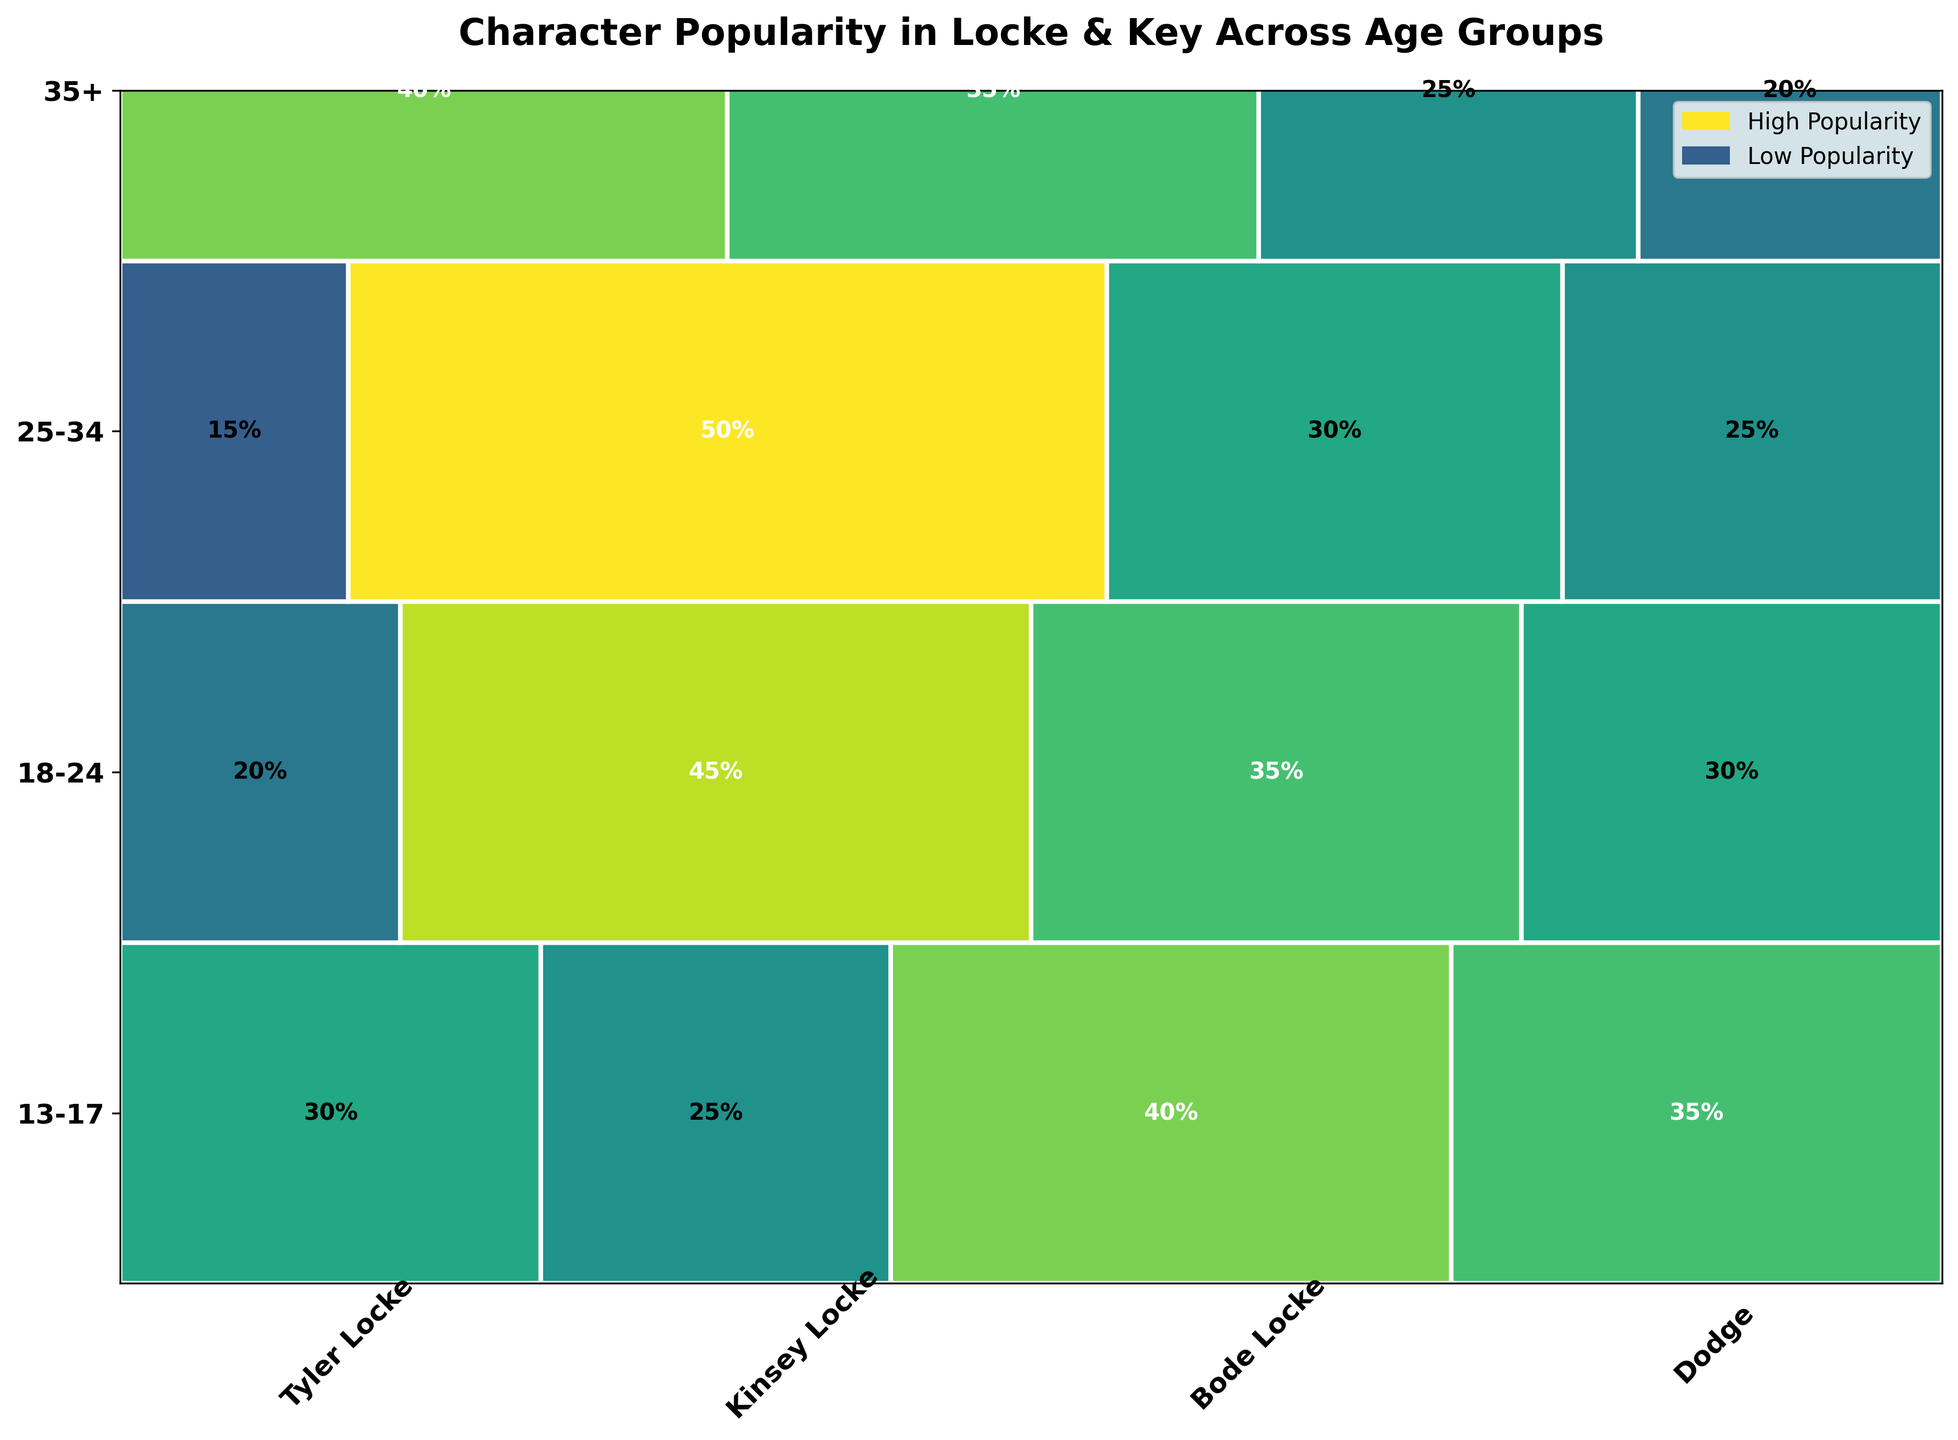Which age group has the highest preference for Dodge? To find the age group with the highest preference for Dodge, look at the section labeled Dodge and visually inspect the height across age groups. The bar for 25-34 is the tallest in the Dodge section.
Answer: 25-34 Who is the least popular character among fans aged 18-24? To identify the least popular character among 18-24, locate the row for 18-24 and find the smallest width bar. Bode Locke's bar has the smallest width.
Answer: Bode Locke How does Bode's popularity compare in the 35+ group versus the 13-17 group? Compare the widths of Bode Locke's section in the 35+ row and the 13-17 row. The bar for Bode Locke is wider in the 35+ age group.
Answer: More popular in 35+ Which character is equally popular among the 13-17 and 25-34 age groups? Look for characters where the bars have the same width in both the 13-17 and 25-34 rows. Kinsey Locke has equal width bars.
Answer: Kinsey Locke What’s the sum of the popularity percentages for Tyler Locke in all age groups? Sum the values given for Tyler Locke: 35 (13-17) + 30 (18-24) + 25 (25-34) + 20 (35+) = 110
Answer: 110 If you combine the popularity percentages for Kinsey Locke and Bode Locke, how does it compare to Dodge in the 25-34 group? Kinsey Locke (30) + Bode Locke (15) = 45. Compare this with Dodge who has 50. Dodge is more popular.
Answer: Dodge is more popular Which character shows a decrease in popularity with increased age? Find the character whose bar gets progressively narrower with increasing age groups. Tyler Locke's bar decreases from 13-17 to 35+.
Answer: Tyler Locke What is the total popularity percentage for all characters among the 35+ age group? Sum the popularity percentages for all characters in the 35+ group: 20 (Tyler Locke) + 25 (Kinsey Locke) + 40 (Bode Locke) + 35 (Dodge) = 120
Answer: 120 Considering all age groups, which character has the least fluctuation in popularity? Compare the widths of the bars for each character across all age groups and identify the one with the steady width. Kinsey Locke appears the most consistent.
Answer: Kinsey Locke Which age group has the most even distribution of character popularity? Look for the age group where the widths of bars are most similar. The 13-17 age group shows relatively even distribution.
Answer: 13-17 